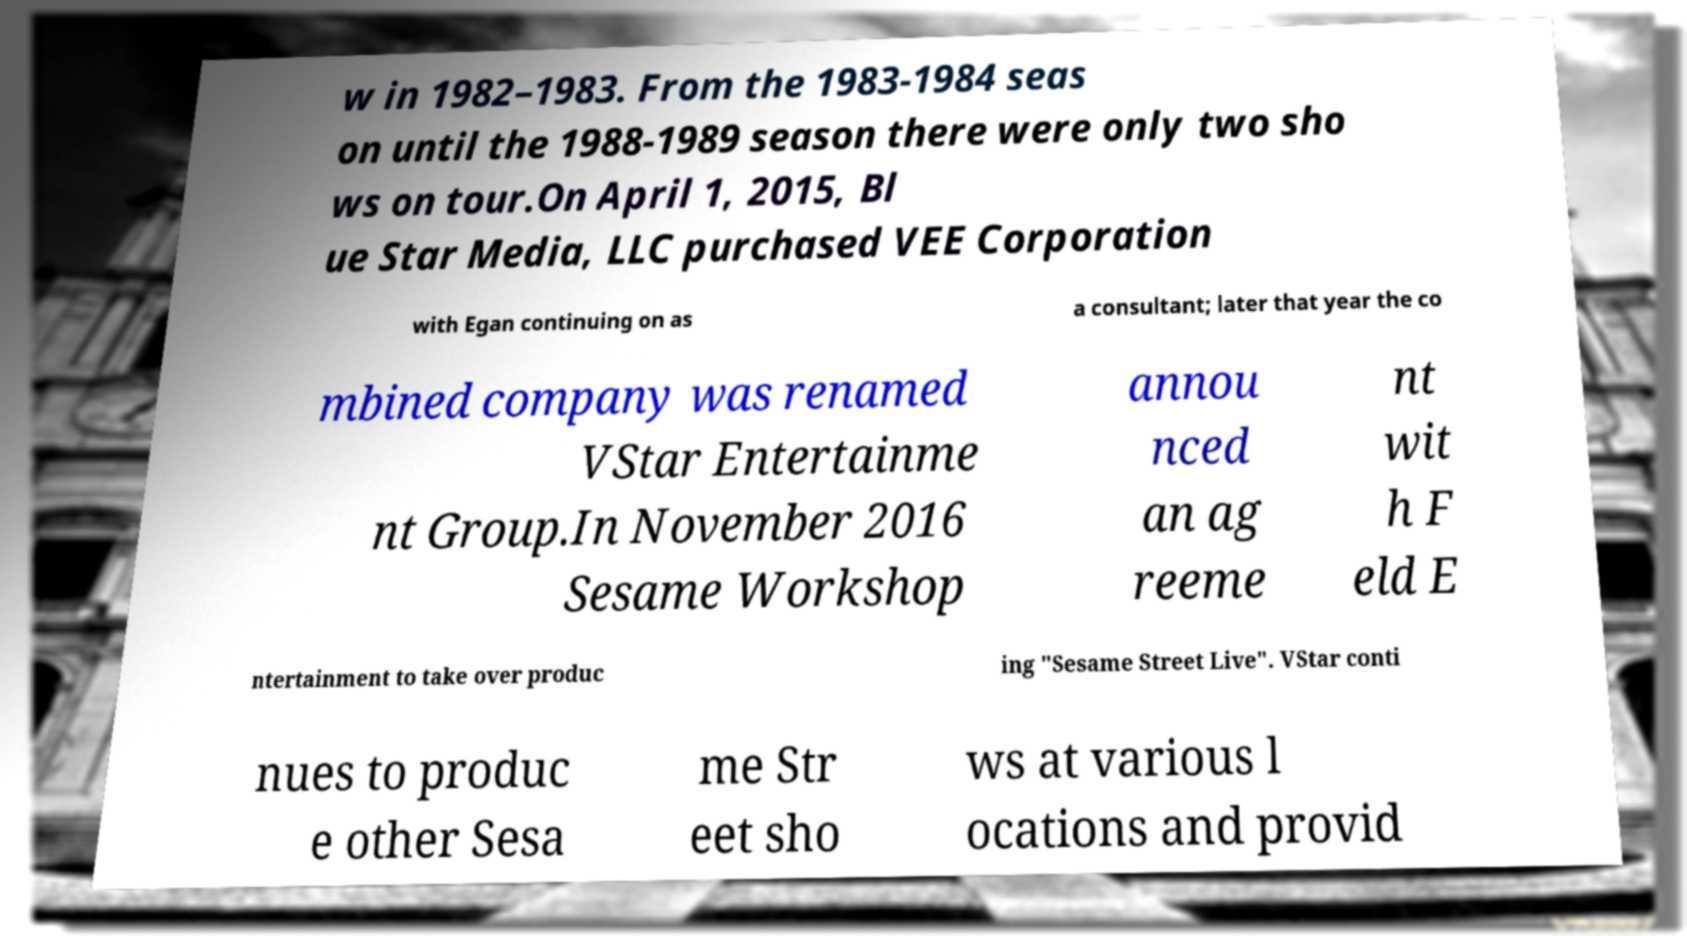Please identify and transcribe the text found in this image. w in 1982–1983. From the 1983-1984 seas on until the 1988-1989 season there were only two sho ws on tour.On April 1, 2015, Bl ue Star Media, LLC purchased VEE Corporation with Egan continuing on as a consultant; later that year the co mbined company was renamed VStar Entertainme nt Group.In November 2016 Sesame Workshop annou nced an ag reeme nt wit h F eld E ntertainment to take over produc ing "Sesame Street Live". VStar conti nues to produc e other Sesa me Str eet sho ws at various l ocations and provid 